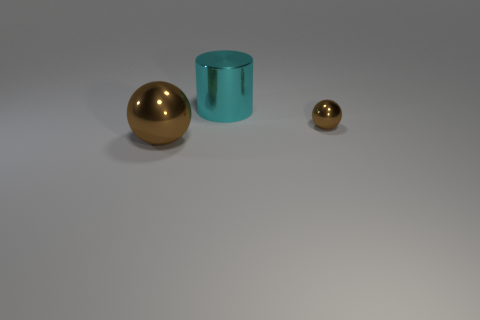There is a big metallic sphere; is it the same color as the sphere behind the large brown metallic object?
Your answer should be compact. Yes. Are there fewer brown shiny balls left of the big cyan shiny thing than large brown metallic objects on the right side of the large ball?
Your answer should be very brief. No. What is the color of the object that is in front of the cyan thing and right of the large brown ball?
Ensure brevity in your answer.  Brown. Is the size of the cyan object the same as the brown sphere on the right side of the cyan object?
Offer a terse response. No. What shape is the large thing behind the big metallic ball?
Offer a very short reply. Cylinder. Is there any other thing that has the same material as the big brown object?
Provide a short and direct response. Yes. Is the number of cyan shiny objects that are behind the big cyan cylinder greater than the number of shiny things?
Your answer should be very brief. No. There is a sphere behind the large metallic object on the left side of the metallic cylinder; what number of shiny balls are to the left of it?
Your response must be concise. 1. Is the size of the brown sphere that is right of the big metal ball the same as the thing to the left of the cyan metallic cylinder?
Ensure brevity in your answer.  No. What is the big thing that is behind the ball that is on the right side of the cyan object made of?
Ensure brevity in your answer.  Metal. 